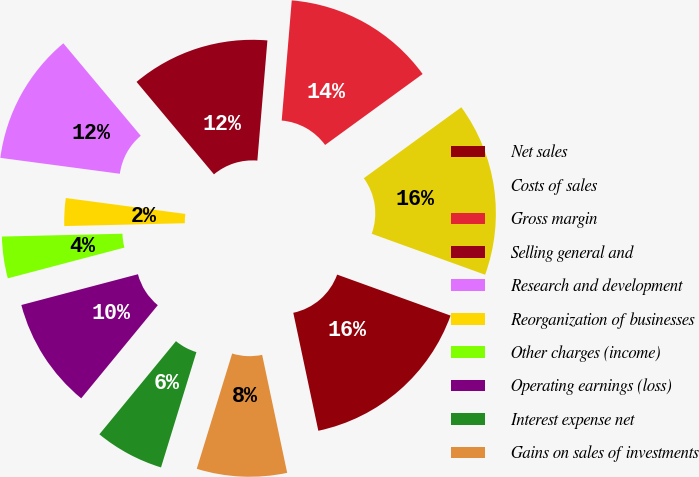Convert chart to OTSL. <chart><loc_0><loc_0><loc_500><loc_500><pie_chart><fcel>Net sales<fcel>Costs of sales<fcel>Gross margin<fcel>Selling general and<fcel>Research and development<fcel>Reorganization of businesses<fcel>Other charges (income)<fcel>Operating earnings (loss)<fcel>Interest expense net<fcel>Gains on sales of investments<nl><fcel>16.15%<fcel>15.53%<fcel>13.66%<fcel>12.42%<fcel>11.8%<fcel>2.48%<fcel>3.73%<fcel>9.94%<fcel>6.21%<fcel>8.07%<nl></chart> 